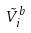Convert formula to latex. <formula><loc_0><loc_0><loc_500><loc_500>\tilde { V } _ { i } ^ { b }</formula> 